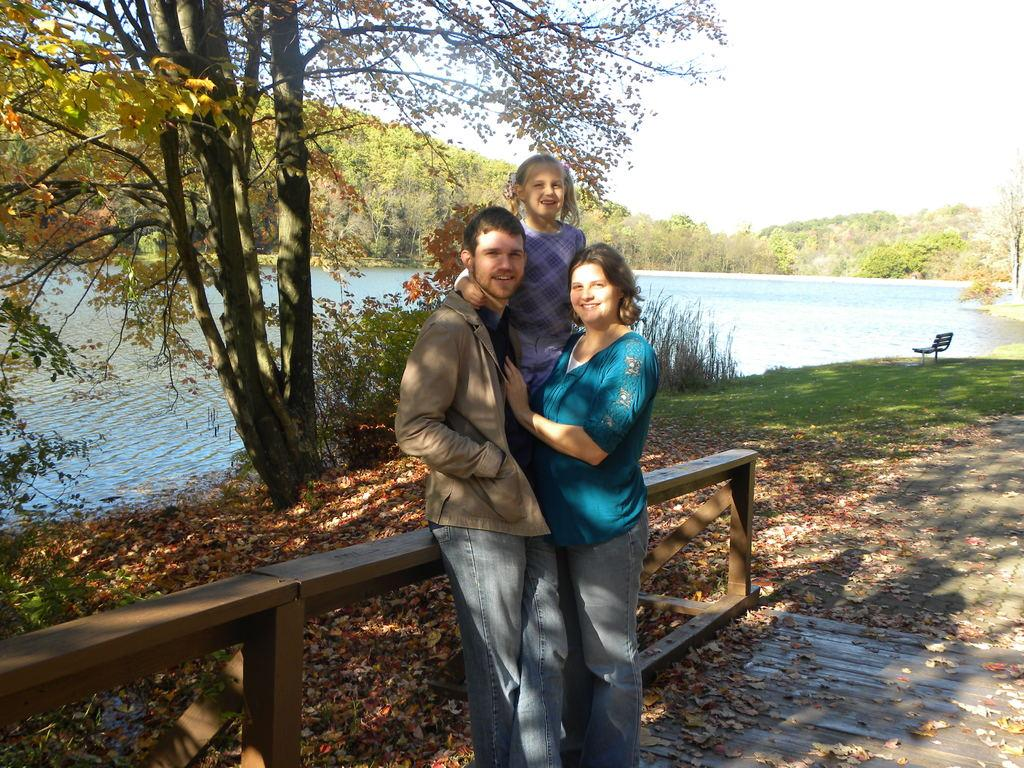How many people are in the image? There are three people in the image. What are the people in the image doing? The three people are posing for a photoshoot. What can be seen in the background of the image? There is water, trees, and the sky visible in the image. What type of furniture is present in the image? There is a bench in the image. Can you see a deer in the image? No, there is no deer present in the image. What is the sun doing in the image? The sun is not an active participant in the image; it is simply visible in the sky. 